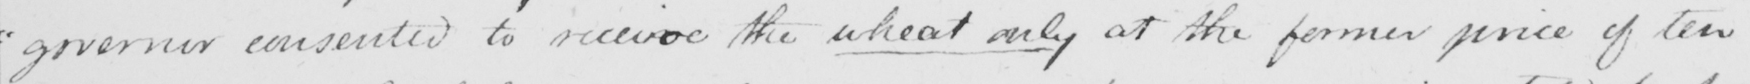Transcribe the text shown in this historical manuscript line. " governor consented to receive the wheat only at the former price of ten 